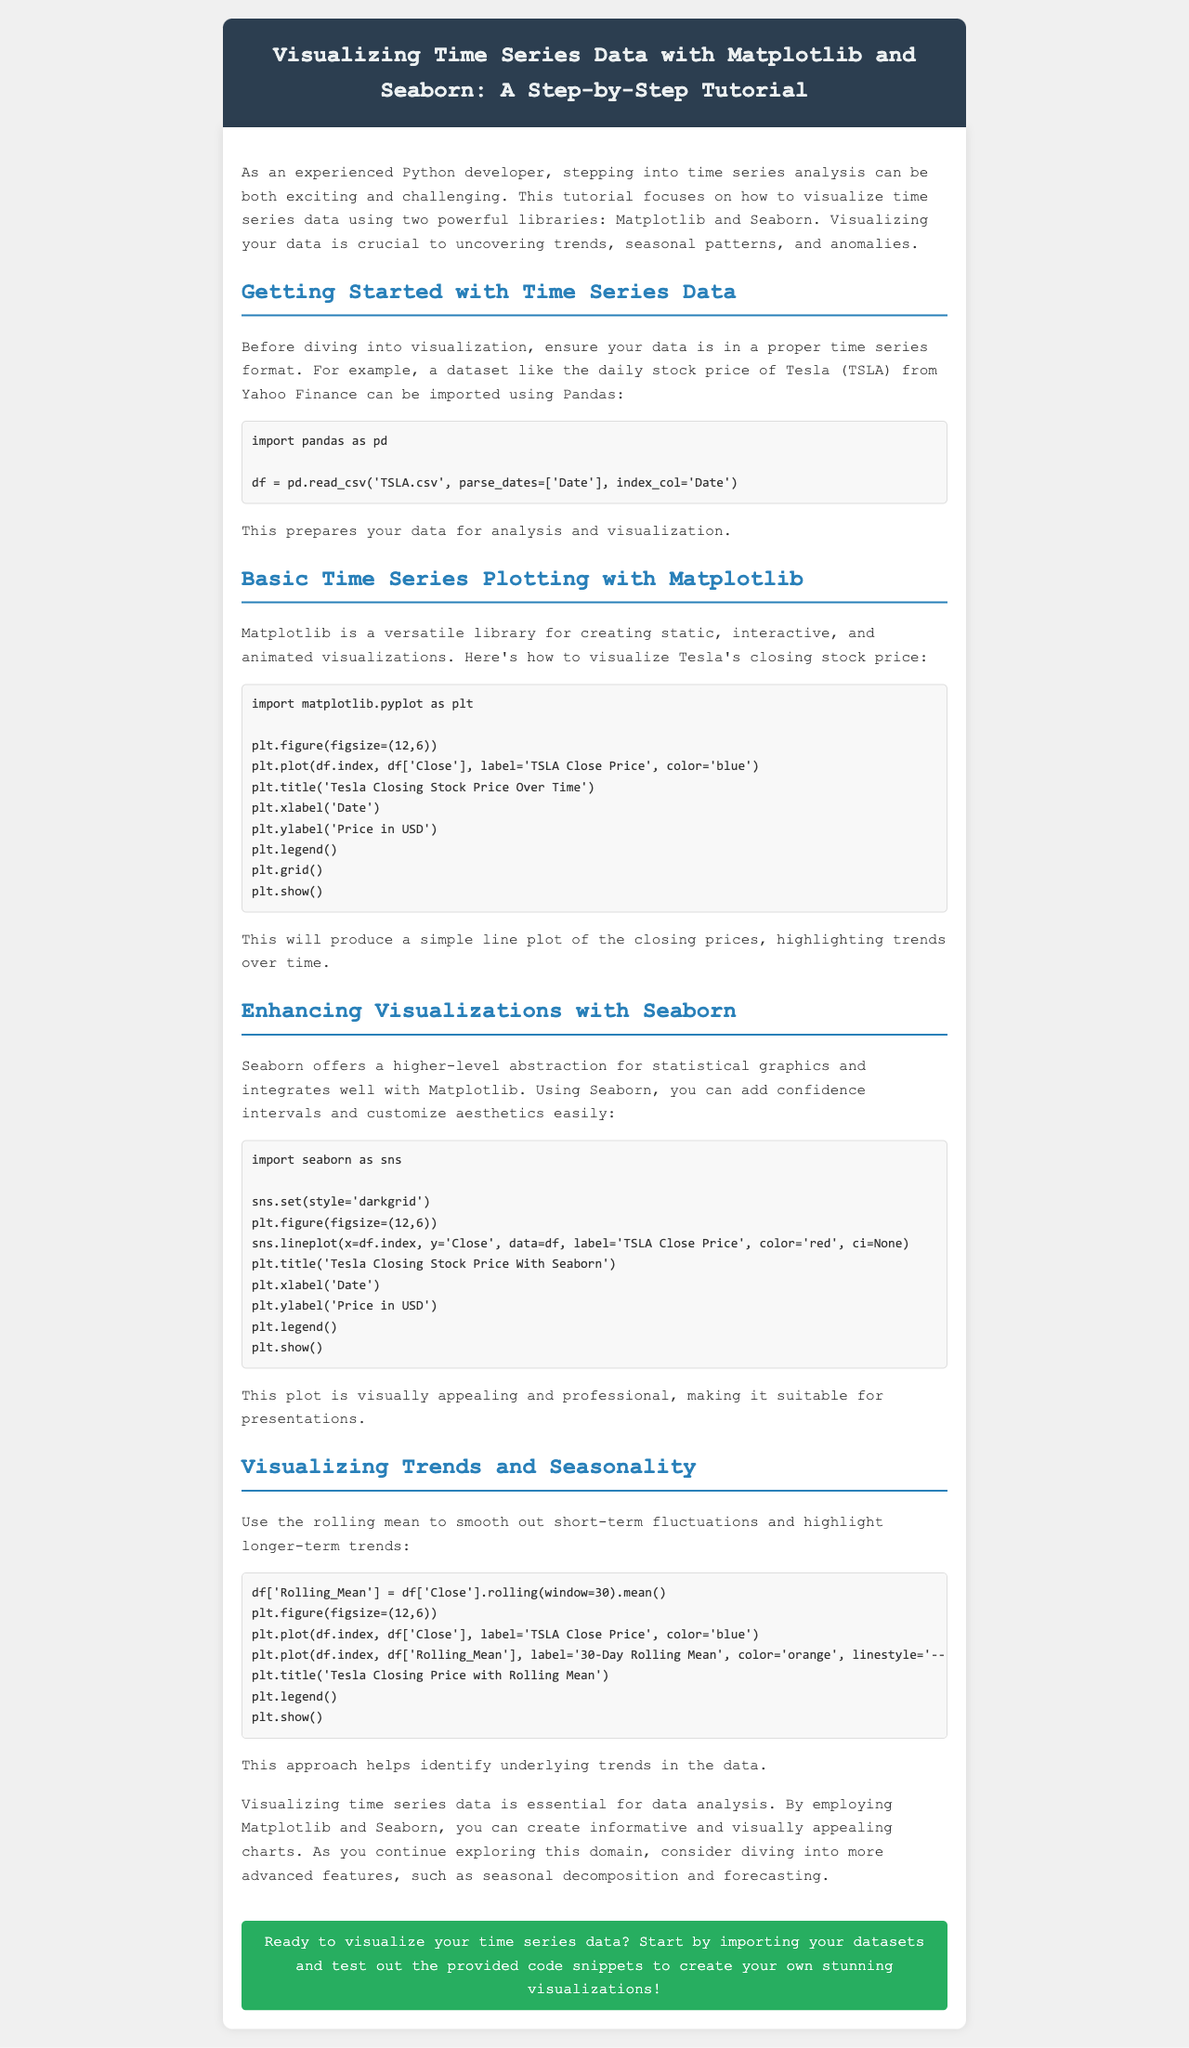What is the main focus of the tutorial? The tutorial focuses on visualizing time series data using Matplotlib and Seaborn.
Answer: Visualizing time series data with Matplotlib and Seaborn What dataset is mentioned as an example for importing? The dataset mentioned is the daily stock price of Tesla.
Answer: Tesla Which library is described as more versatile for creating visualizations? Matplotlib is described as a versatile library for creating visualizations.
Answer: Matplotlib What color is used for the line plot of Tesla's closing stock price in Matplotlib? The line plot for Tesla's closing stock price is colored blue.
Answer: Blue What is the window size used for calculating the rolling mean? The rolling mean uses a window size of 30 days.
Answer: 30 Which library offers a higher-level abstraction for statistical graphics? Seaborn is the library that offers a higher-level abstraction.
Answer: Seaborn What is the main benefit of using the rolling mean in trend visualization? It helps to smooth out short-term fluctuations and highlight longer-term trends.
Answer: Smoothing short-term fluctuations Which aesthetic style does Seaborn use in the example provided? Seaborn uses the 'darkgrid' style in the visualization example.
Answer: darkgrid What action does the call-to-action encourage readers to take? The call-to-action encourages readers to start importing datasets and test the code.
Answer: Import datasets and test the code 